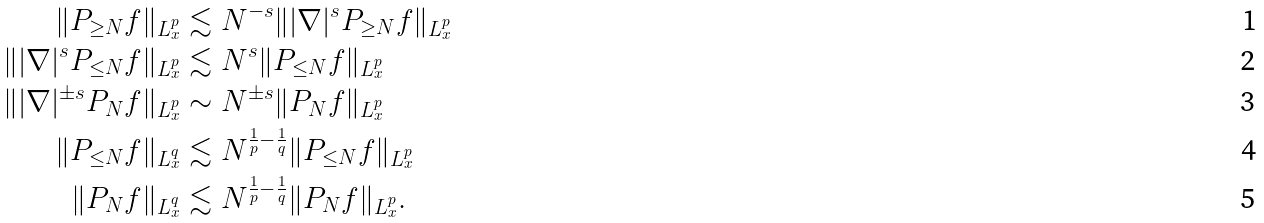<formula> <loc_0><loc_0><loc_500><loc_500>\| P _ { \geq N } f \| _ { L ^ { p } _ { x } } & \lesssim N ^ { - s } \| | \nabla | ^ { s } P _ { \geq N } f \| _ { L ^ { p } _ { x } } \\ \| | \nabla | ^ { s } P _ { \leq N } f \| _ { L ^ { p } _ { x } } & \lesssim N ^ { s } \| P _ { \leq N } f \| _ { L ^ { p } _ { x } } \\ \| | \nabla | ^ { \pm s } P _ { N } f \| _ { L ^ { p } _ { x } } & \sim N ^ { \pm s } \| P _ { N } f \| _ { L ^ { p } _ { x } } \\ \| P _ { \leq N } f \| _ { L ^ { q } _ { x } } & \lesssim N ^ { \frac { 1 } { p } - \frac { 1 } { q } } \| P _ { \leq N } f \| _ { L ^ { p } _ { x } } \\ \| P _ { N } f \| _ { L ^ { q } _ { x } } & \lesssim N ^ { \frac { 1 } { p } - \frac { 1 } { q } } \| P _ { N } f \| _ { L ^ { p } _ { x } } .</formula> 